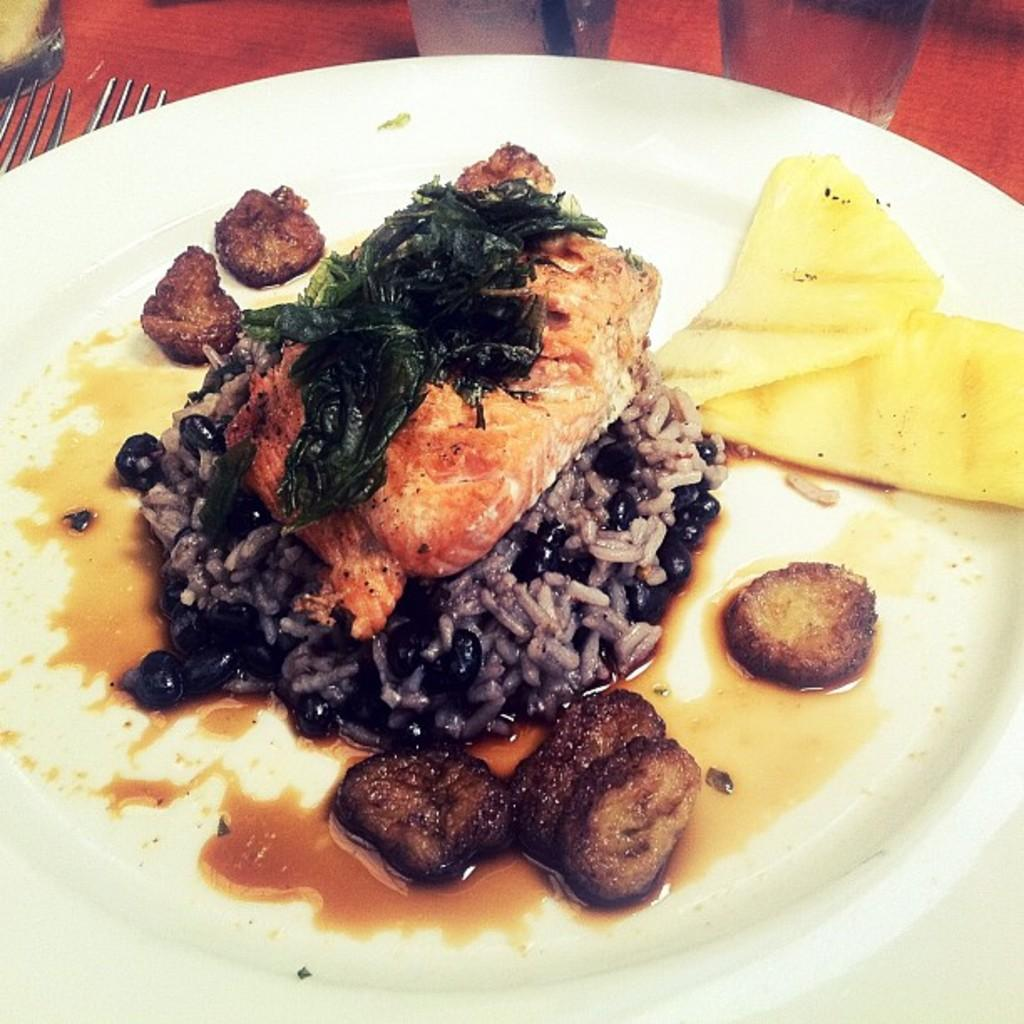What is located in the foreground of the image? There is a plate in the foreground of the image. What is on the plate? There are food items on the plate. What utensils can be seen in the background of the image? There are spoons and forks in the background of the image. What type of clouds can be seen in the image? There are no clouds present in the image; it features a plate with food items and utensils in the background. 